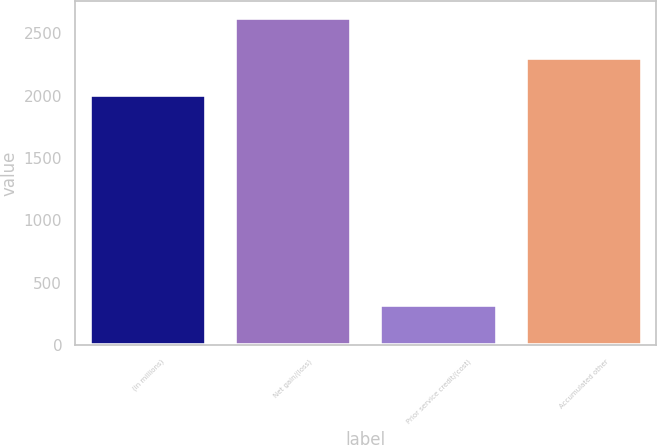<chart> <loc_0><loc_0><loc_500><loc_500><bar_chart><fcel>(in millions)<fcel>Net gain/(loss)<fcel>Prior service credit/(cost)<fcel>Accumulated other<nl><fcel>2010<fcel>2627<fcel>321<fcel>2306<nl></chart> 